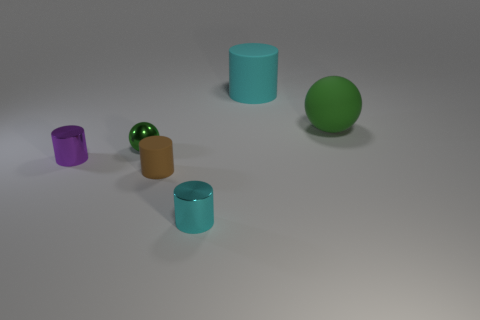Add 3 large yellow cubes. How many objects exist? 9 Subtract all cylinders. How many objects are left? 2 Add 4 tiny cyan cylinders. How many tiny cyan cylinders are left? 5 Add 1 big cyan cylinders. How many big cyan cylinders exist? 2 Subtract 1 purple cylinders. How many objects are left? 5 Subtract all balls. Subtract all big gray things. How many objects are left? 4 